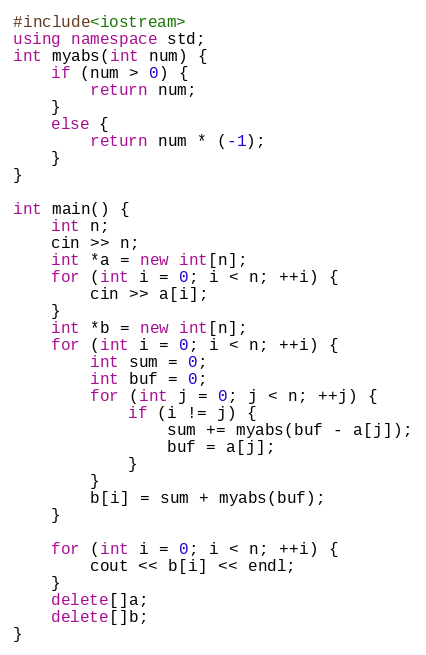Convert code to text. <code><loc_0><loc_0><loc_500><loc_500><_C++_>#include<iostream>
using namespace std;
int myabs(int num) {
	if (num > 0) {
		return num;
	}
	else {
		return num * (-1);
	}
}

int main() {
	int n;
	cin >> n;
	int *a = new int[n];
	for (int i = 0; i < n; ++i) {
		cin >> a[i];
	}
	int *b = new int[n];
	for (int i = 0; i < n; ++i) {
		int sum = 0;
		int buf = 0;
		for (int j = 0; j < n; ++j) {
			if (i != j) {
				sum += myabs(buf - a[j]);
				buf = a[j];
			}
		}
		b[i] = sum + myabs(buf);
	}

	for (int i = 0; i < n; ++i) {
		cout << b[i] << endl;
	}
	delete[]a;
	delete[]b;
}</code> 